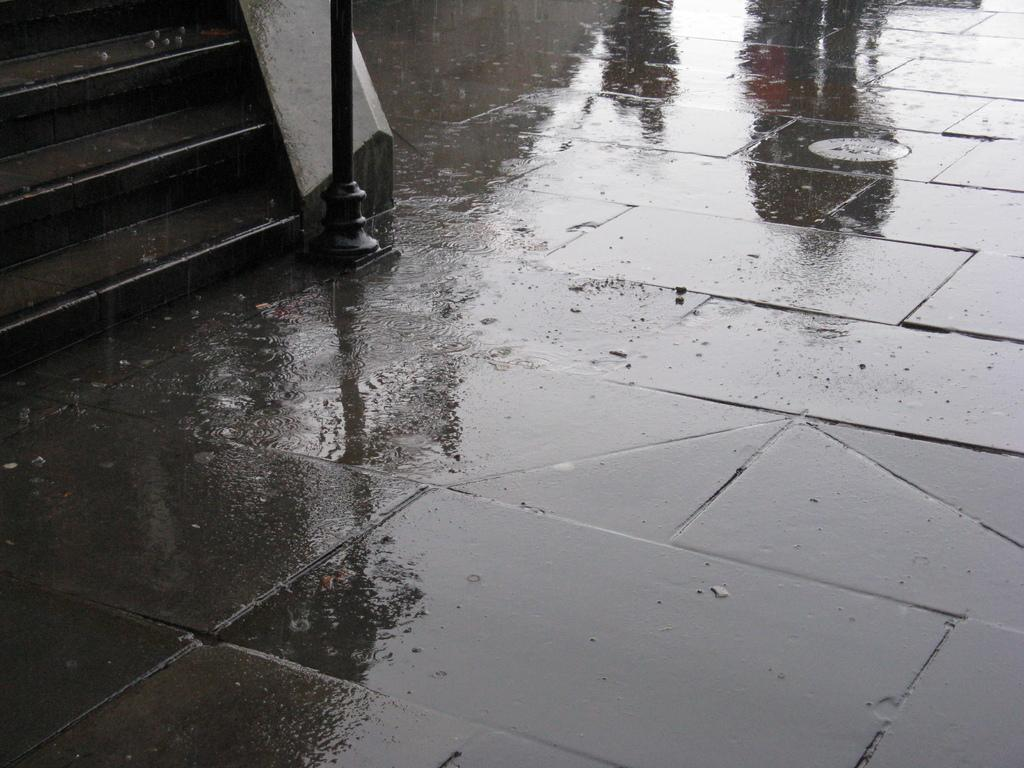What type of flooring is present in the image? There is a concrete floor in the image. Where are the stairs located in the image? The stairs are on the left side of the image. What is in the center of the image? There is a pole in the center of the image. What can be seen in the image besides the floor, stairs, and pole? Water is visible in the image. What type of plant is growing on the pole in the image? There is no plant growing on the pole in the image. Are there any people wearing masks in the image? There are no people or masks present in the image. 